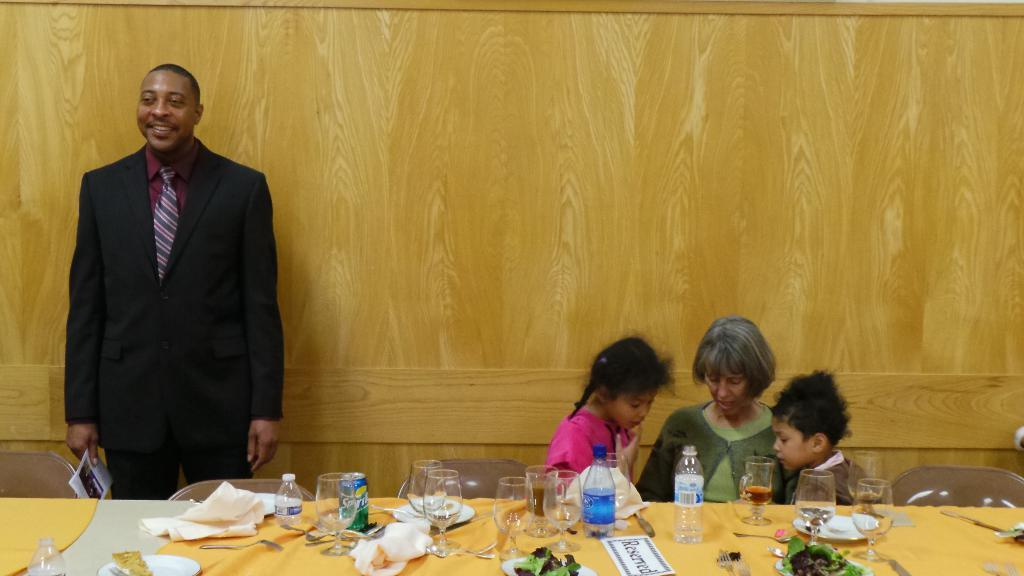What is the position of the guy in the image? The guy is standing on the left side of the image. How many children are present in the image? There are two kids in the image. Who else is present in the image besides the guy and the kids? There is a woman in the image. What are the two kids and the woman doing in the image? The two kids and the woman are sitting on a table. What else can be seen on the table besides the people? There are food eatables on the table. What type of structure is the guy using to keep his scarf in place in the image? There is no scarf present in the image, and therefore no structure to keep it in place. 